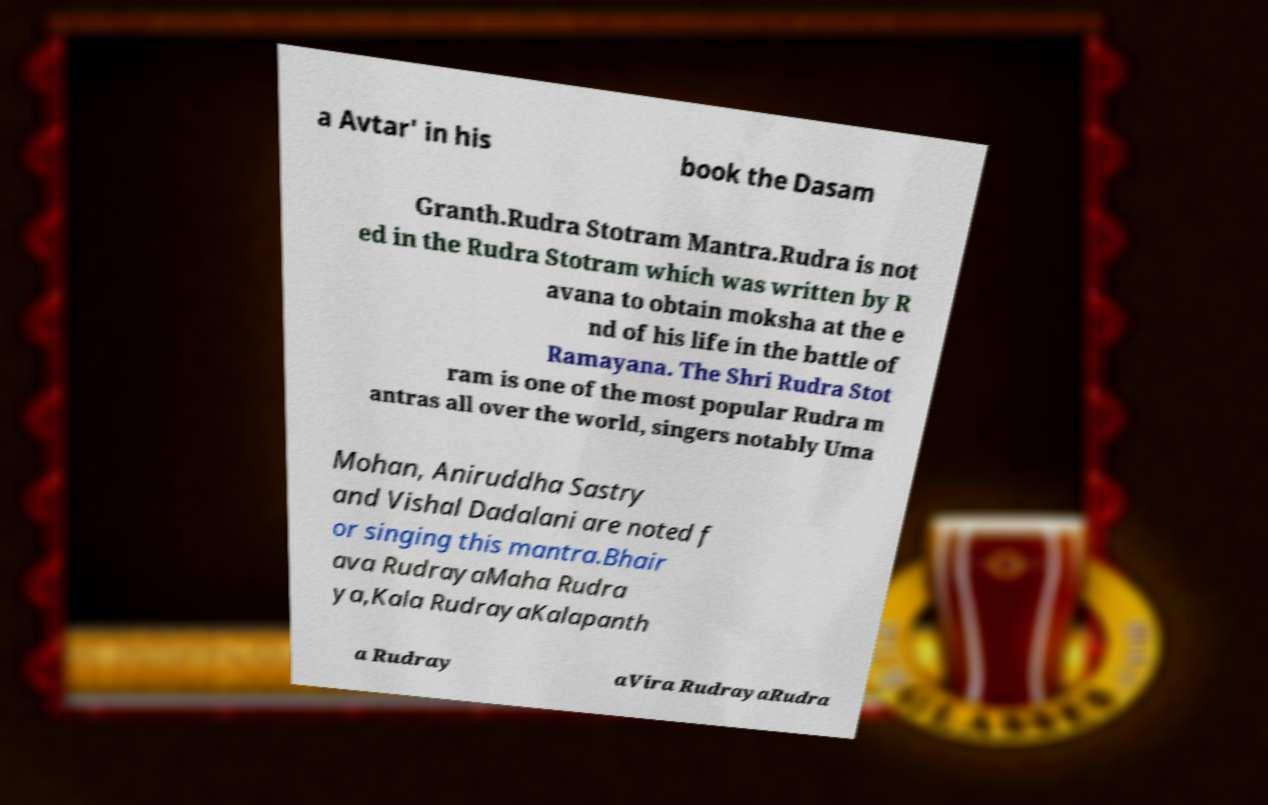Please identify and transcribe the text found in this image. a Avtar' in his book the Dasam Granth.Rudra Stotram Mantra.Rudra is not ed in the Rudra Stotram which was written by R avana to obtain moksha at the e nd of his life in the battle of Ramayana. The Shri Rudra Stot ram is one of the most popular Rudra m antras all over the world, singers notably Uma Mohan, Aniruddha Sastry and Vishal Dadalani are noted f or singing this mantra.Bhair ava RudrayaMaha Rudra ya,Kala RudrayaKalapanth a Rudray aVira RudrayaRudra 